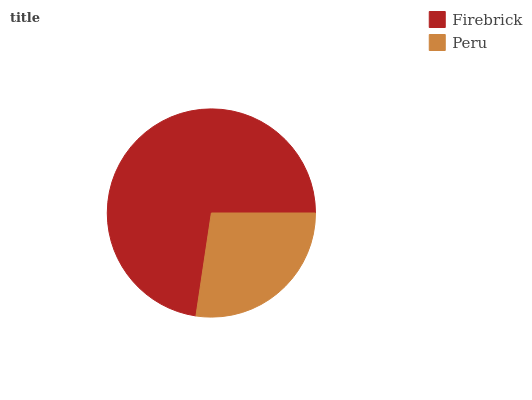Is Peru the minimum?
Answer yes or no. Yes. Is Firebrick the maximum?
Answer yes or no. Yes. Is Peru the maximum?
Answer yes or no. No. Is Firebrick greater than Peru?
Answer yes or no. Yes. Is Peru less than Firebrick?
Answer yes or no. Yes. Is Peru greater than Firebrick?
Answer yes or no. No. Is Firebrick less than Peru?
Answer yes or no. No. Is Firebrick the high median?
Answer yes or no. Yes. Is Peru the low median?
Answer yes or no. Yes. Is Peru the high median?
Answer yes or no. No. Is Firebrick the low median?
Answer yes or no. No. 